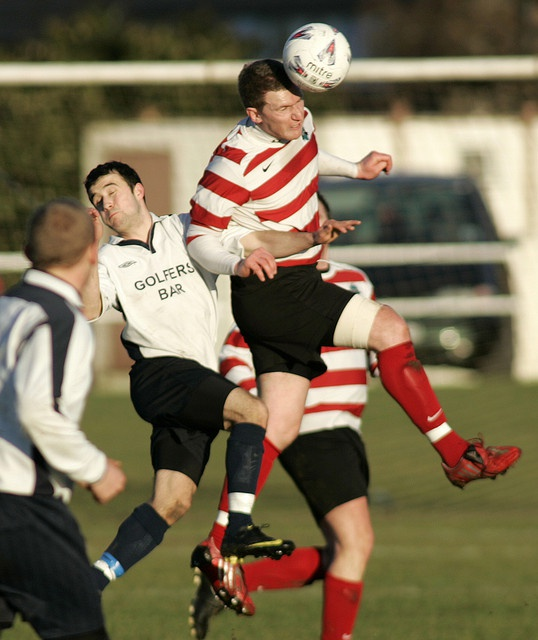Describe the objects in this image and their specific colors. I can see people in black, beige, brown, and tan tones, people in black, beige, and tan tones, people in black, beige, olive, and gray tones, people in black, brown, ivory, and olive tones, and car in black, gray, and darkgreen tones in this image. 